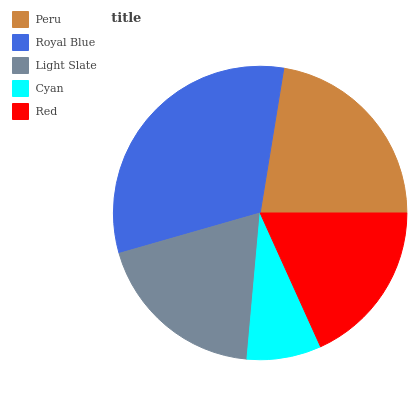Is Cyan the minimum?
Answer yes or no. Yes. Is Royal Blue the maximum?
Answer yes or no. Yes. Is Light Slate the minimum?
Answer yes or no. No. Is Light Slate the maximum?
Answer yes or no. No. Is Royal Blue greater than Light Slate?
Answer yes or no. Yes. Is Light Slate less than Royal Blue?
Answer yes or no. Yes. Is Light Slate greater than Royal Blue?
Answer yes or no. No. Is Royal Blue less than Light Slate?
Answer yes or no. No. Is Light Slate the high median?
Answer yes or no. Yes. Is Light Slate the low median?
Answer yes or no. Yes. Is Cyan the high median?
Answer yes or no. No. Is Cyan the low median?
Answer yes or no. No. 